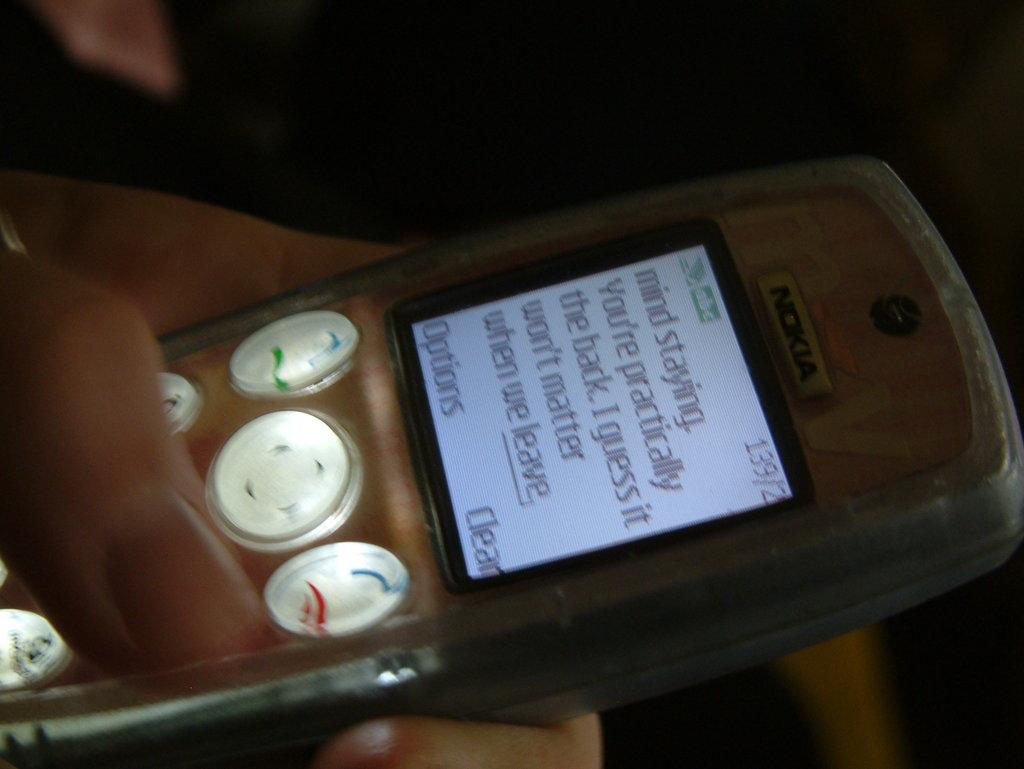<image>
Offer a succinct explanation of the picture presented. hand holding phone with text message displaying mind staying, you're practically the back i guess it won't matter when we leave 